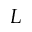<formula> <loc_0><loc_0><loc_500><loc_500>L</formula> 